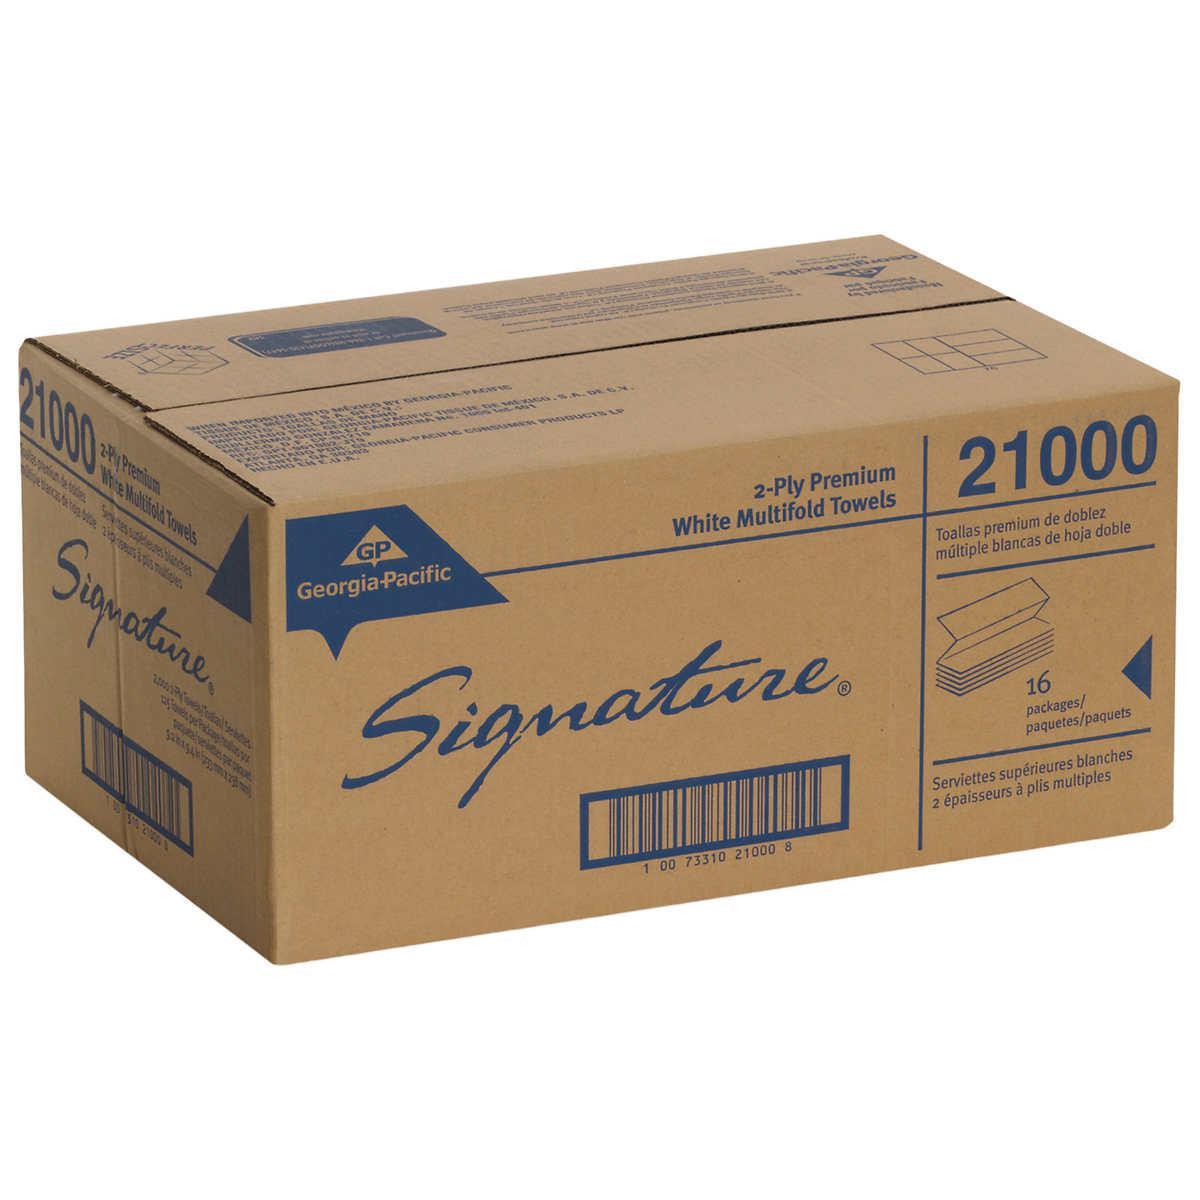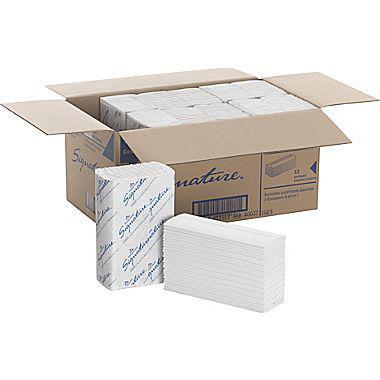The first image is the image on the left, the second image is the image on the right. For the images displayed, is the sentence "One image shows a brown paper-wrapped bundle of folded paper towels with a few unwrapped towels in front of it, but no image includes a tall stack of unwrapped folded paper towels." factually correct? Answer yes or no. No. The first image is the image on the left, the second image is the image on the right. Analyze the images presented: Is the assertion "There is a least one stack of towels wrapped in brown paper" valid? Answer yes or no. No. 